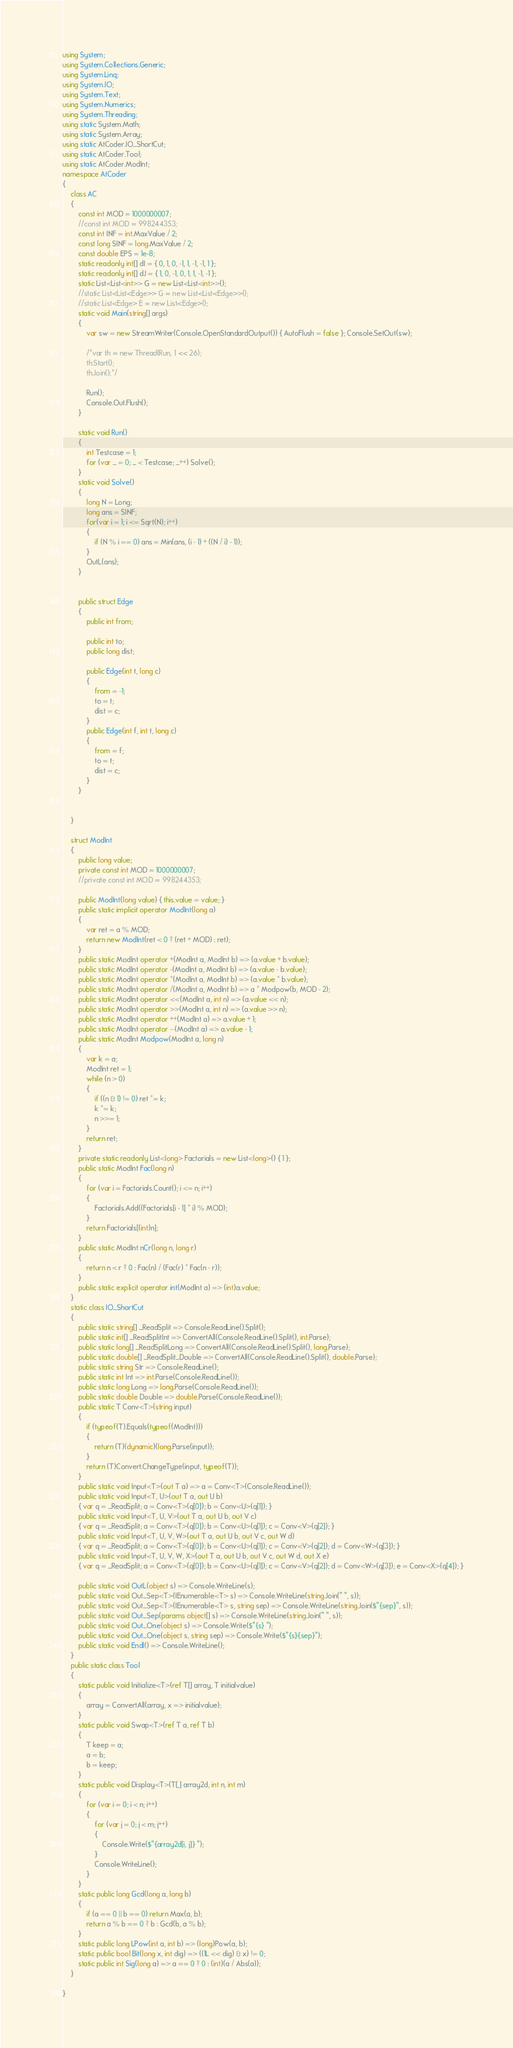<code> <loc_0><loc_0><loc_500><loc_500><_C#_>using System;
using System.Collections.Generic;
using System.Linq;
using System.IO;
using System.Text;
using System.Numerics;
using System.Threading;
using static System.Math;
using static System.Array;
using static AtCoder.IO_ShortCut;
using static AtCoder.Tool;
using static AtCoder.ModInt;
namespace AtCoder
{
    class AC
    {
        const int MOD = 1000000007;
        //const int MOD = 998244353;
        const int INF = int.MaxValue / 2;
        const long SINF = long.MaxValue / 2;
        const double EPS = 1e-8;
        static readonly int[] dI = { 0, 1, 0, -1, 1, -1, -1, 1 };
        static readonly int[] dJ = { 1, 0, -1, 0, 1, 1, -1, -1 };
        static List<List<int>> G = new List<List<int>>();
        //static List<List<Edge>> G = new List<List<Edge>>();
        //static List<Edge> E = new List<Edge>();
        static void Main(string[] args)
        {
            var sw = new StreamWriter(Console.OpenStandardOutput()) { AutoFlush = false }; Console.SetOut(sw);

            /*var th = new Thread(Run, 1 << 26);
            th.Start();
            th.Join();*/

            Run();
            Console.Out.Flush();
        }

        static void Run()
        {
            int Testcase = 1;
            for (var _ = 0; _ < Testcase; _++) Solve();
        }
        static void Solve()
        {
            long N = Long;
            long ans = SINF;
            for(var i = 1; i <= Sqrt(N); i++)
            {
                if (N % i == 0) ans = Min(ans, (i - 1) + ((N / i) - 1));
            }
            OutL(ans);
        }
        

        public struct Edge
        {
            public int from;

            public int to;
            public long dist;

            public Edge(int t, long c)
            {
                from = -1;
                to = t;
                dist = c;
            }
            public Edge(int f, int t, long c)
            {
                from = f;
                to = t;
                dist = c;
            }
        }
        

    }
    
    struct ModInt
    {
        public long value;
        private const int MOD = 1000000007;
        //private const int MOD = 998244353;

        public ModInt(long value) { this.value = value; }
        public static implicit operator ModInt(long a)
        {
            var ret = a % MOD;
            return new ModInt(ret < 0 ? (ret + MOD) : ret);
        }
        public static ModInt operator +(ModInt a, ModInt b) => (a.value + b.value);
        public static ModInt operator -(ModInt a, ModInt b) => (a.value - b.value);
        public static ModInt operator *(ModInt a, ModInt b) => (a.value * b.value);
        public static ModInt operator /(ModInt a, ModInt b) => a * Modpow(b, MOD - 2);
        public static ModInt operator <<(ModInt a, int n) => (a.value << n);
        public static ModInt operator >>(ModInt a, int n) => (a.value >> n);
        public static ModInt operator ++(ModInt a) => a.value + 1;
        public static ModInt operator --(ModInt a) => a.value - 1;
        public static ModInt Modpow(ModInt a, long n)
        {
            var k = a;
            ModInt ret = 1;
            while (n > 0)
            {
                if ((n & 1) != 0) ret *= k;
                k *= k;
                n >>= 1;
            }
            return ret;
        }
        private static readonly List<long> Factorials = new List<long>() { 1 };
        public static ModInt Fac(long n)
        {
            for (var i = Factorials.Count(); i <= n; i++)
            {
                Factorials.Add((Factorials[i - 1] * i) % MOD);
            }
            return Factorials[(int)n];
        }
        public static ModInt nCr(long n, long r)
        {
            return n < r ? 0 : Fac(n) / (Fac(r) * Fac(n - r));
        }
        public static explicit operator int(ModInt a) => (int)a.value;
    }
    static class IO_ShortCut
    {
        public static string[] _ReadSplit => Console.ReadLine().Split();
        public static int[] _ReadSplitInt => ConvertAll(Console.ReadLine().Split(), int.Parse);
        public static long[] _ReadSplitLong => ConvertAll(Console.ReadLine().Split(), long.Parse);
        public static double[] _ReadSplit_Double => ConvertAll(Console.ReadLine().Split(), double.Parse);
        public static string Str => Console.ReadLine();
        public static int Int => int.Parse(Console.ReadLine());
        public static long Long => long.Parse(Console.ReadLine());
        public static double Double => double.Parse(Console.ReadLine());
        public static T Conv<T>(string input)
        {
            if (typeof(T).Equals(typeof(ModInt)))
            {
                return (T)(dynamic)(long.Parse(input));
            }
            return (T)Convert.ChangeType(input, typeof(T));
        }
        public static void Input<T>(out T a) => a = Conv<T>(Console.ReadLine());
        public static void Input<T, U>(out T a, out U b)
        { var q = _ReadSplit; a = Conv<T>(q[0]); b = Conv<U>(q[1]); }
        public static void Input<T, U, V>(out T a, out U b, out V c)
        { var q = _ReadSplit; a = Conv<T>(q[0]); b = Conv<U>(q[1]); c = Conv<V>(q[2]); }
        public static void Input<T, U, V, W>(out T a, out U b, out V c, out W d)
        { var q = _ReadSplit; a = Conv<T>(q[0]); b = Conv<U>(q[1]); c = Conv<V>(q[2]); d = Conv<W>(q[3]); }
        public static void Input<T, U, V, W, X>(out T a, out U b, out V c, out W d, out X e)
        { var q = _ReadSplit; a = Conv<T>(q[0]); b = Conv<U>(q[1]); c = Conv<V>(q[2]); d = Conv<W>(q[3]); e = Conv<X>(q[4]); }

        public static void OutL(object s) => Console.WriteLine(s);
        public static void Out_Sep<T>(IEnumerable<T> s) => Console.WriteLine(string.Join(" ", s));
        public static void Out_Sep<T>(IEnumerable<T> s, string sep) => Console.WriteLine(string.Join($"{sep}", s));
        public static void Out_Sep(params object[] s) => Console.WriteLine(string.Join(" ", s));
        public static void Out_One(object s) => Console.Write($"{s} ");
        public static void Out_One(object s, string sep) => Console.Write($"{s}{sep}");
        public static void Endl() => Console.WriteLine();
    }
    public static class Tool
    {
        static public void Initialize<T>(ref T[] array, T initialvalue)
        {
            array = ConvertAll(array, x => initialvalue);
        }
        static public void Swap<T>(ref T a, ref T b)
        {
            T keep = a;
            a = b;
            b = keep;
        }
        static public void Display<T>(T[,] array2d, int n, int m)
        {
            for (var i = 0; i < n; i++)
            {
                for (var j = 0; j < m; j++)
                {
                    Console.Write($"{array2d[i, j]} ");
                }
                Console.WriteLine();
            }
        }
        static public long Gcd(long a, long b)
        {
            if (a == 0 || b == 0) return Max(a, b);
            return a % b == 0 ? b : Gcd(b, a % b);
        }
        static public long LPow(int a, int b) => (long)Pow(a, b);
        static public bool Bit(long x, int dig) => ((1L << dig) & x) != 0;
        static public int Sig(long a) => a == 0 ? 0 : (int)(a / Abs(a));
    }
    
}
</code> 